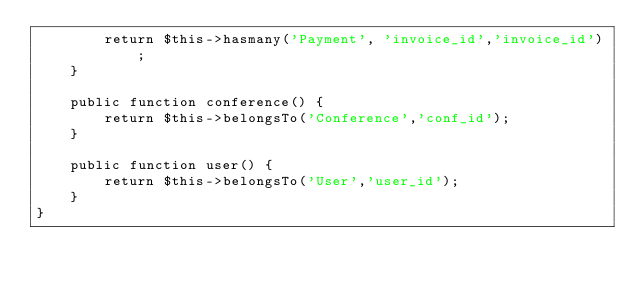Convert code to text. <code><loc_0><loc_0><loc_500><loc_500><_PHP_>		return $this->hasmany('Payment', 'invoice_id','invoice_id');
	}

	public function conference() {
		return $this->belongsTo('Conference','conf_id');
	}

	public function user() {
		return $this->belongsTo('User','user_id');
	}
}


 </code> 